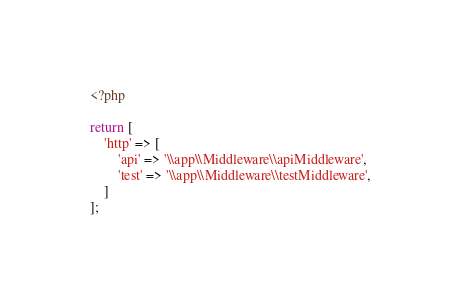Convert code to text. <code><loc_0><loc_0><loc_500><loc_500><_PHP_><?php

return [
	'http' => [
		'api' => '\\app\\Middleware\\apiMiddleware',
		'test' => '\\app\\Middleware\\testMiddleware',
	]
];</code> 